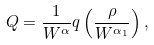<formula> <loc_0><loc_0><loc_500><loc_500>Q = \frac { 1 } { W ^ { \alpha } } q \left ( \frac { \rho } { W ^ { \alpha _ { 1 } } } \right ) ,</formula> 